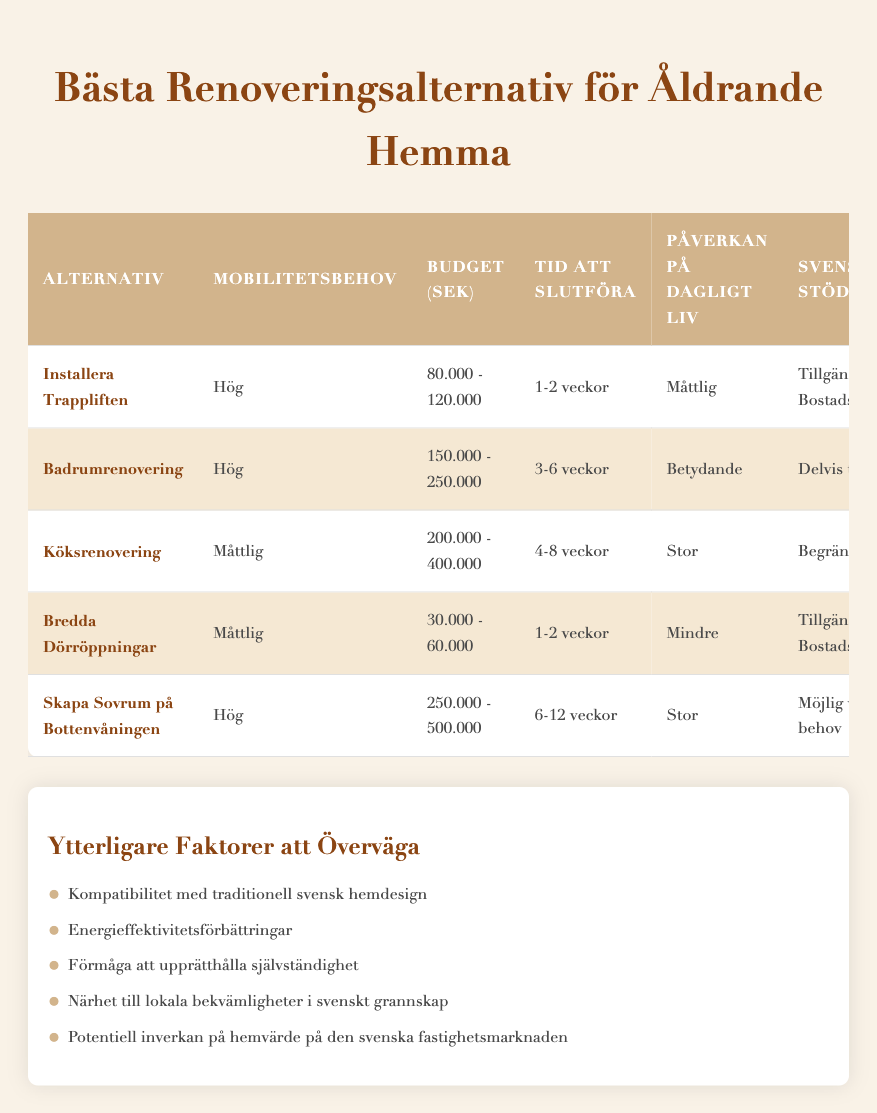What is the budget range for installing a stairlift? The information for installing a stairlift states that the budget range is from 80,000 to 120,000 SEK. This can be directly retrieved from the "Budget (SEK)" column for the "Install Stairlift" option.
Answer: 80,000 - 120,000 SEK Which renovation options have a high mobility need? The options listed with a high mobility need are "Install Stairlift", "Bathroom Remodel", and "Create First-Floor Bedroom". This can be found by filtering the "Mobility Needs" column for "High".
Answer: Install Stairlift, Bathroom Remodel, Create First-Floor Bedroom What is the average budget range for the options that require high mobility needs? The budget ranges for the high mobility needs are 80,000 - 120,000 SEK (stairlift), 150,000 - 250,000 SEK (bathroom remodel), and 250,000 - 500,000 SEK (first-floor bedroom). Converting these ranges to numerical values for calculation: 100,000 (average for stairlift), 200,000 (average for bathroom remodel), and 375,000 (average for first-floor bedroom). The average will be (100,000 + 200,000 + 375,000)/3 = 225,000.
Answer: 225,000 SEK Does government assistance cover the installation of a stairlift? The entry for the stairlift indicates "Available through Bostadsanpassningsbidrag". Therefore, there is government assistance available for the installation of a stairlift.
Answer: Yes Which option takes the longest time to complete? The "Create First-Floor Bedroom" option states that it takes 6-12 weeks to complete, which is longer than any other option listed. This information is gathered from the "Time to Complete" column.
Answer: Create First-Floor Bedroom How many weeks does it take, on average, to complete a bathroom remodel and kitchen renovation? The bathroom remodel takes 3-6 weeks, averaging 4.5 weeks. The kitchen renovation takes 4-8 weeks, averaging 6 weeks. Adding these averages results in 4.5 + 6 = 10.5 weeks, and dividing by 2 gives an average of 5.25 weeks.
Answer: 5.25 weeks Is it true that widening doorways has low impact on daily life? The impact on daily life for the "Widen Doorways" option is stated as "Minor". Therefore, it is indeed true that widening doorways has a low impact.
Answer: Yes Which renovation option has the most significant impact on daily life? The "Bathroom Remodel" option indicates a "Significant" impact on daily life, which is the highest level of impact listed. This can be verified by checking the "Impact on Daily Life" column.
Answer: Bathroom Remodel 